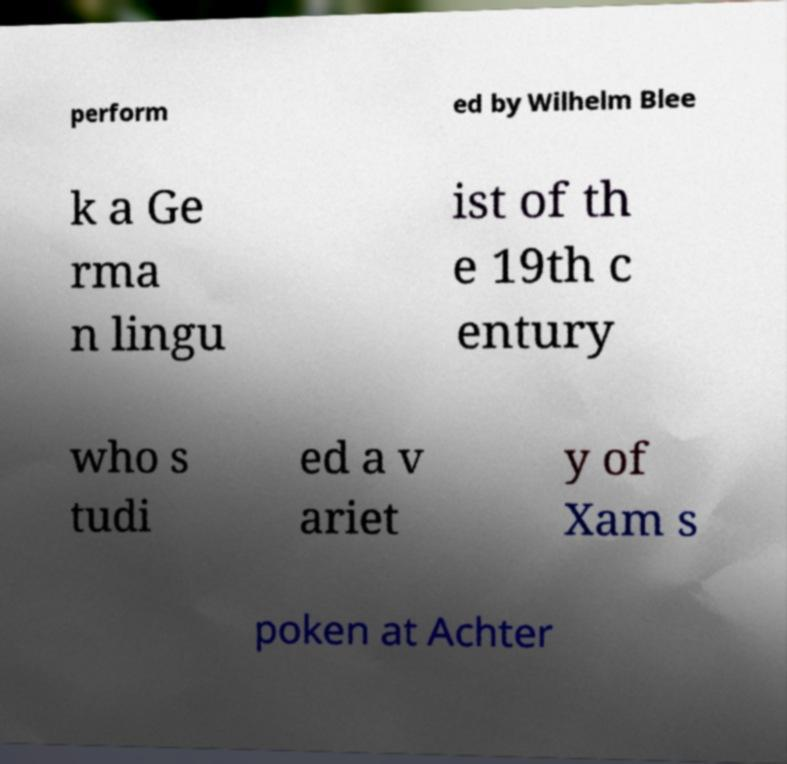Could you assist in decoding the text presented in this image and type it out clearly? perform ed by Wilhelm Blee k a Ge rma n lingu ist of th e 19th c entury who s tudi ed a v ariet y of Xam s poken at Achter 